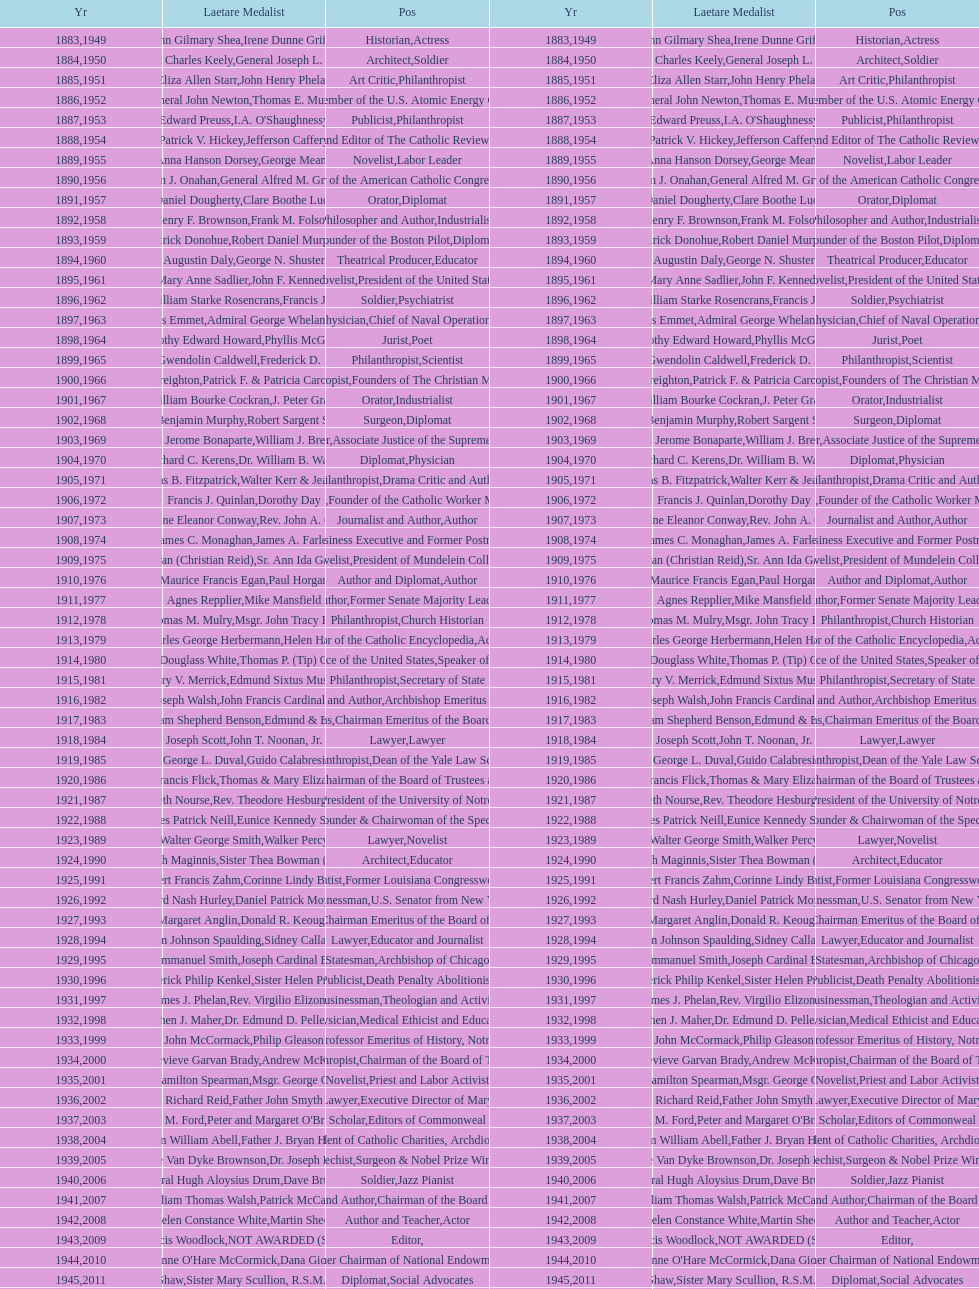How many lawyers have won the award between 1883 and 2014? 5. 